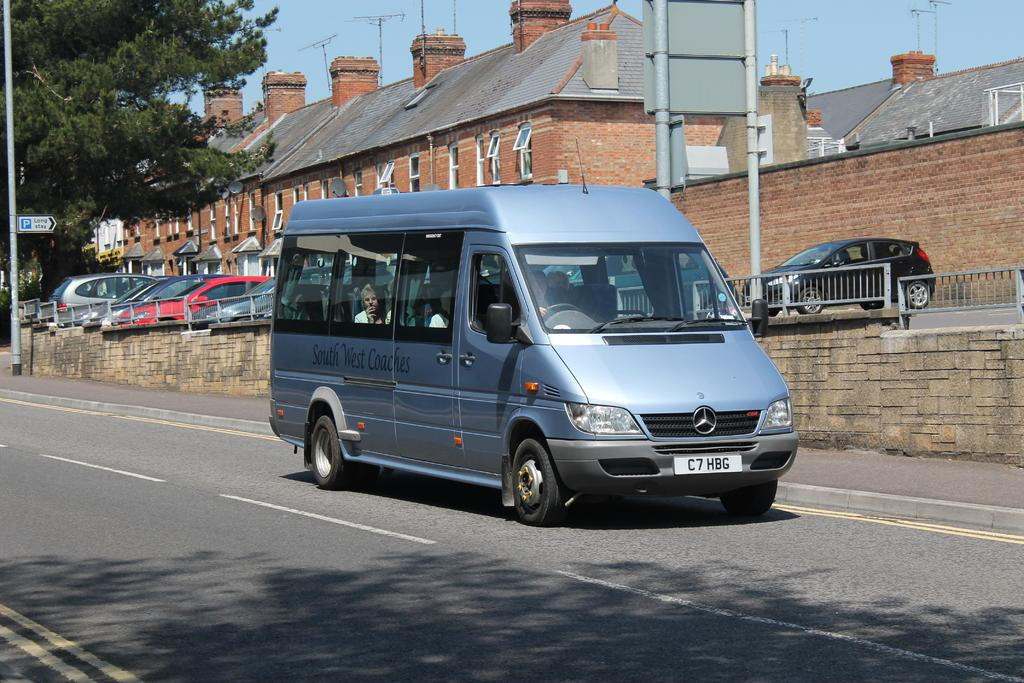<image>
Write a terse but informative summary of the picture. A blue silver van with a license plate that says C7HBG. 